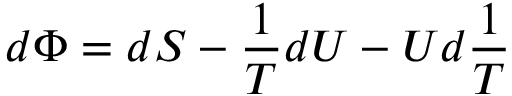<formula> <loc_0><loc_0><loc_500><loc_500>d \Phi = d S - { \frac { 1 } { T } } d U - U d { \frac { 1 } { T } }</formula> 